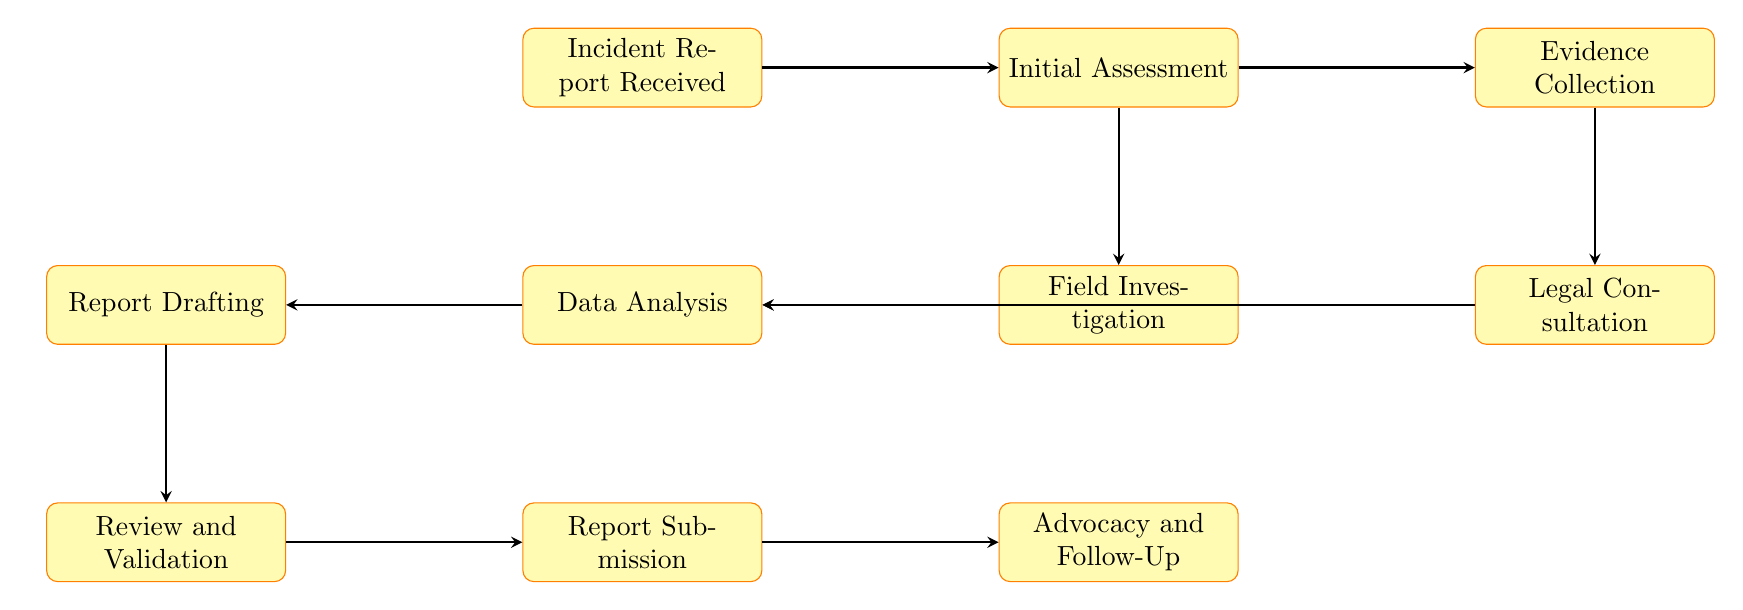What is the first node in the flow chart? The first node indicates the starting point of the process, which is the "Incident Report Received".
Answer: Incident Report Received How many nodes are in the flow chart? By counting all the nodes listed in the diagram, we can see there are ten distinct nodes, starting from "Incident Report Received" to "Advocacy and Follow-Up".
Answer: Ten What follows after the "Initial Assessment"? The flow chart depicts the sequence from "Initial Assessment" to "Evidence Collection", indicating that "Evidence Collection" follows directly.
Answer: Evidence Collection What two nodes lead to "Data Analysis"? The diagram shows that "Field Investigation" and "Legal Consultation" both lead to "Data Analysis", meaning evidence and legal insight are inputs into this analysis step.
Answer: Field Investigation, Legal Consultation Which node is responsible for drafting the report? In the flow chart, after data analysis is finished, the next step is to prepare the report in the "Report Drafting" node.
Answer: Report Drafting What is the last step of the investigation process? The last step in the sequence portrayed in the flow chart is "Advocacy and Follow-Up", indicating that actions are taken based on the findings of the report.
Answer: Advocacy and Follow-Up How does "Evidence Collection" connect to "Legal Consultation"? The flow chart shows that "Evidence Collection" leads directly to "Legal Consultation", indicating evidence gathered may influence or inform legal advice.
Answer: Directly connects Which node represents the submission of the findings? In the flow chart, "Report Submission" represents the stage where the findings of the investigation are formally submitted to stakeholders.
Answer: Report Submission Which two steps are the last before submitting the report? The steps immediately preceding "Report Submission" are "Review and Validation" and "Report Drafting", which ensure the report is accurate before submission.
Answer: Review and Validation, Report Drafting 